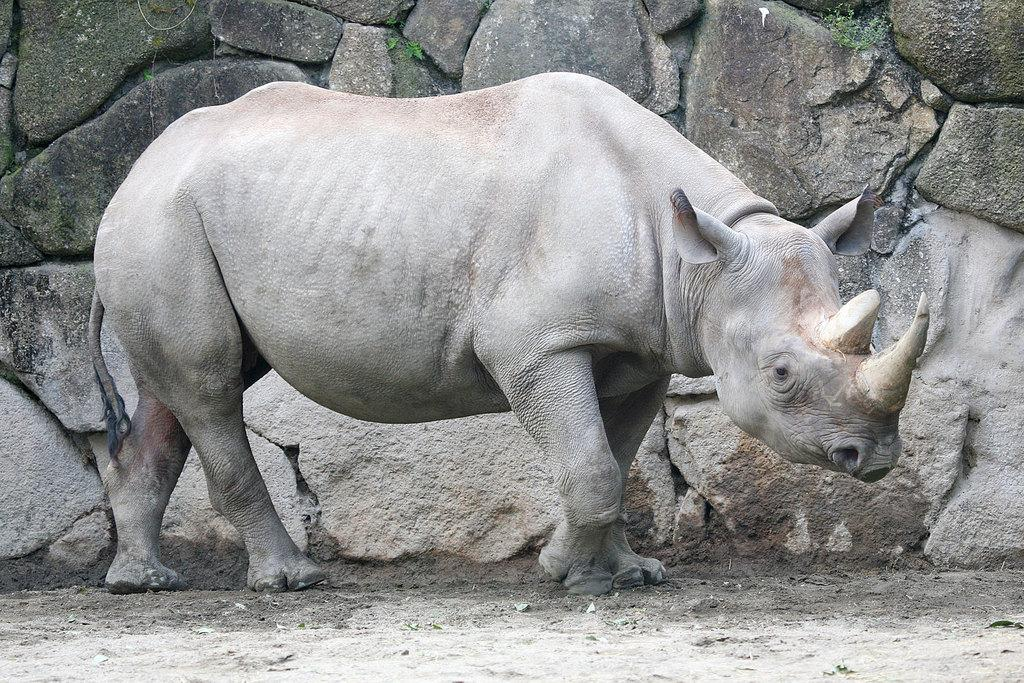What animal is the main subject of the image? There is a rhinoceros in the image. What can be seen behind the rhinoceros? There are rocks behind the rhinoceros. What type of scarf is the rhinoceros wearing in the image? There is no scarf present in the image; the rhinoceros is not wearing any clothing. 